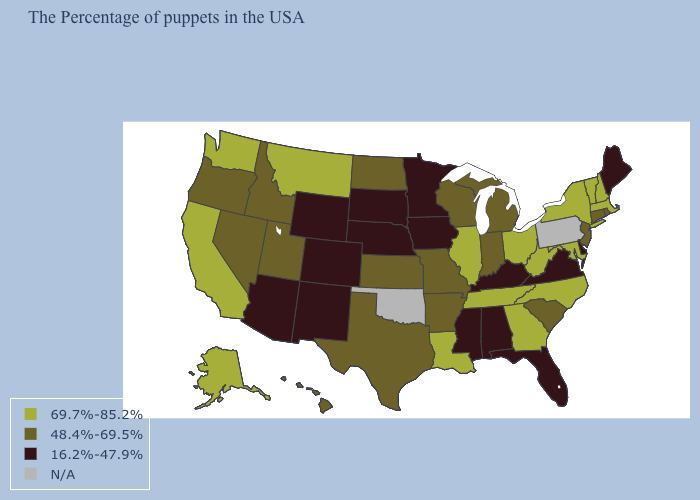Among the states that border Nebraska , which have the highest value?
Concise answer only. Missouri, Kansas. What is the lowest value in the USA?
Be succinct. 16.2%-47.9%. How many symbols are there in the legend?
Answer briefly. 4. Does New Mexico have the lowest value in the West?
Quick response, please. Yes. Among the states that border Illinois , which have the lowest value?
Concise answer only. Kentucky, Iowa. Which states have the highest value in the USA?
Give a very brief answer. Massachusetts, New Hampshire, Vermont, New York, Maryland, North Carolina, West Virginia, Ohio, Georgia, Tennessee, Illinois, Louisiana, Montana, California, Washington, Alaska. Does New Jersey have the lowest value in the USA?
Be succinct. No. What is the lowest value in the MidWest?
Be succinct. 16.2%-47.9%. Which states have the lowest value in the USA?
Write a very short answer. Maine, Delaware, Virginia, Florida, Kentucky, Alabama, Mississippi, Minnesota, Iowa, Nebraska, South Dakota, Wyoming, Colorado, New Mexico, Arizona. How many symbols are there in the legend?
Be succinct. 4. What is the highest value in the USA?
Concise answer only. 69.7%-85.2%. What is the value of Wyoming?
Keep it brief. 16.2%-47.9%. Name the states that have a value in the range 69.7%-85.2%?
Concise answer only. Massachusetts, New Hampshire, Vermont, New York, Maryland, North Carolina, West Virginia, Ohio, Georgia, Tennessee, Illinois, Louisiana, Montana, California, Washington, Alaska. What is the value of Maine?
Keep it brief. 16.2%-47.9%. 